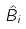Convert formula to latex. <formula><loc_0><loc_0><loc_500><loc_500>\hat { B } _ { i }</formula> 